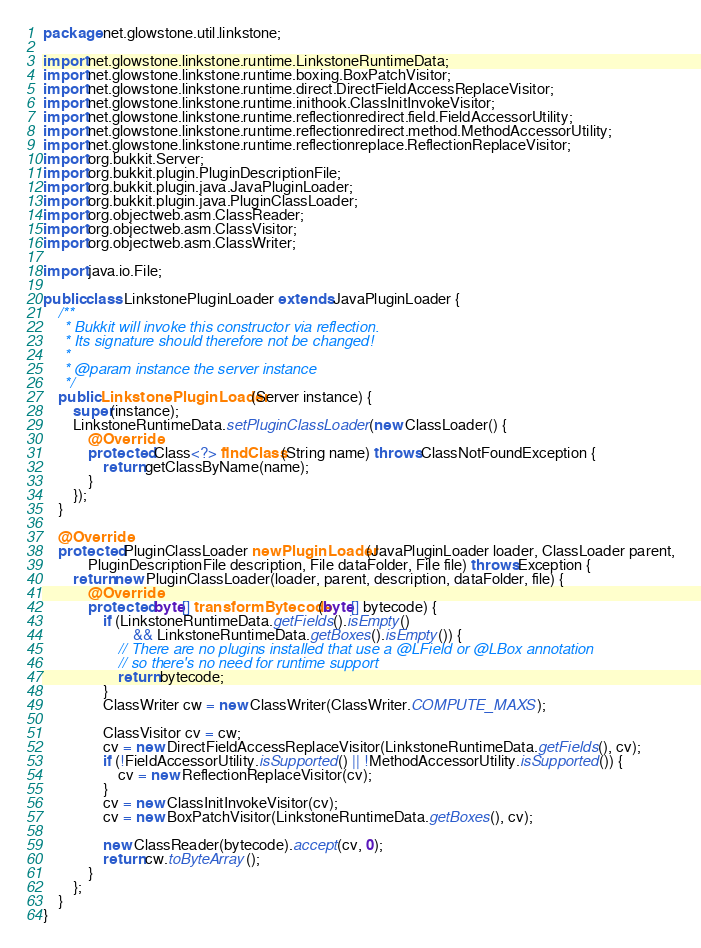Convert code to text. <code><loc_0><loc_0><loc_500><loc_500><_Java_>package net.glowstone.util.linkstone;

import net.glowstone.linkstone.runtime.LinkstoneRuntimeData;
import net.glowstone.linkstone.runtime.boxing.BoxPatchVisitor;
import net.glowstone.linkstone.runtime.direct.DirectFieldAccessReplaceVisitor;
import net.glowstone.linkstone.runtime.inithook.ClassInitInvokeVisitor;
import net.glowstone.linkstone.runtime.reflectionredirect.field.FieldAccessorUtility;
import net.glowstone.linkstone.runtime.reflectionredirect.method.MethodAccessorUtility;
import net.glowstone.linkstone.runtime.reflectionreplace.ReflectionReplaceVisitor;
import org.bukkit.Server;
import org.bukkit.plugin.PluginDescriptionFile;
import org.bukkit.plugin.java.JavaPluginLoader;
import org.bukkit.plugin.java.PluginClassLoader;
import org.objectweb.asm.ClassReader;
import org.objectweb.asm.ClassVisitor;
import org.objectweb.asm.ClassWriter;

import java.io.File;

public class LinkstonePluginLoader extends JavaPluginLoader {
    /**
     * Bukkit will invoke this constructor via reflection.
     * Its signature should therefore not be changed!
     *
     * @param instance the server instance
     */
    public LinkstonePluginLoader(Server instance) {
        super(instance);
        LinkstoneRuntimeData.setPluginClassLoader(new ClassLoader() {
            @Override
            protected Class<?> findClass(String name) throws ClassNotFoundException {
                return getClassByName(name);
            }
        });
    }

    @Override
    protected PluginClassLoader newPluginLoader(JavaPluginLoader loader, ClassLoader parent,
            PluginDescriptionFile description, File dataFolder, File file) throws Exception {
        return new PluginClassLoader(loader, parent, description, dataFolder, file) {
            @Override
            protected byte[] transformBytecode(byte[] bytecode) {
                if (LinkstoneRuntimeData.getFields().isEmpty()
                        && LinkstoneRuntimeData.getBoxes().isEmpty()) {
                    // There are no plugins installed that use a @LField or @LBox annotation
                    // so there's no need for runtime support
                    return bytecode;
                }
                ClassWriter cw = new ClassWriter(ClassWriter.COMPUTE_MAXS);

                ClassVisitor cv = cw;
                cv = new DirectFieldAccessReplaceVisitor(LinkstoneRuntimeData.getFields(), cv);
                if (!FieldAccessorUtility.isSupported() || !MethodAccessorUtility.isSupported()) {
                    cv = new ReflectionReplaceVisitor(cv);
                }
                cv = new ClassInitInvokeVisitor(cv);
                cv = new BoxPatchVisitor(LinkstoneRuntimeData.getBoxes(), cv);

                new ClassReader(bytecode).accept(cv, 0);
                return cw.toByteArray();
            }
        };
    }
}
</code> 